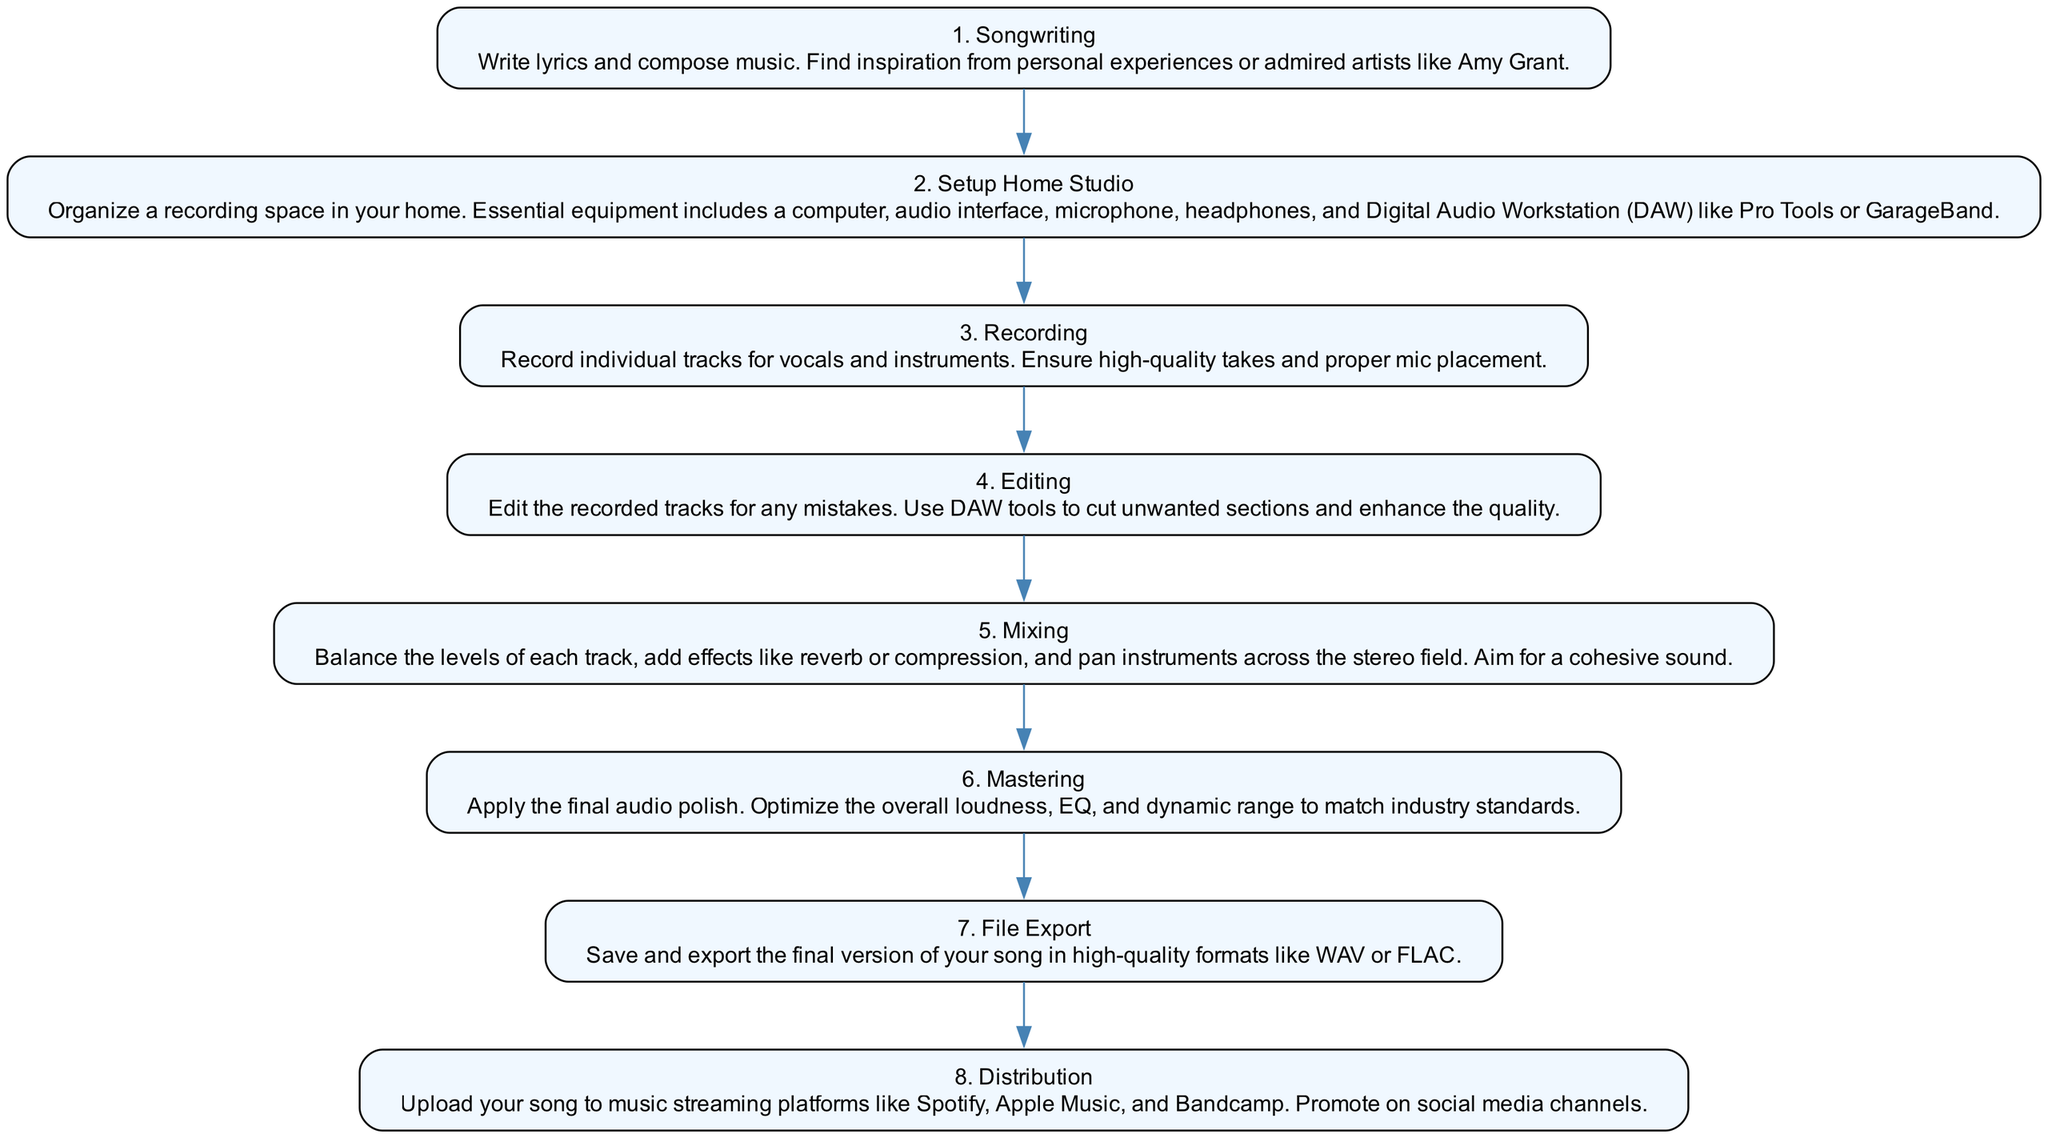What is the first step in the process? The diagram indicates that the first step is "Songwriting." By looking at the top of the flow chart, I can see the title for the first node, confirming that this is the initial action in the process.
Answer: Songwriting How many steps are included in the diagram? By counting the nodes from "Songwriting" to "Distribution," I can see that there are a total of eight distinct steps represented in the flow chart.
Answer: 8 What is the title of the last step? The final node in the flow chart is "Distribution." I observe the text in the last step and verify that it is correctly labeled.
Answer: Distribution Which step involves organizing a recording space? Upon examining the nodes, the second step "Setup Home Studio" focuses on organizing a space for recording. This is directly stated in the description of that specific step, confirming its purpose.
Answer: Setup Home Studio What is the main action in step 5? In step 5 titled "Mixing," the main action is to balance levels of each track, which suggests the importance of achieving a cohesive sound. This can be determined from the description that elaborates on the activities involved in this step.
Answer: Mixing What comes immediately after recording? The flow of the diagram shows that after the "Recording" step, the next action is "Editing." This is evident as there is a direct edge leading from the "Recording" node to the "Editing" node in the flow chart.
Answer: Editing How many types of audio formats are mentioned in the last step? Looking at the last step "File Export," it specifies high-quality formats like WAV or FLAC. Therefore, only two audio formats are discussed here, which I can count directly from the description.
Answer: 2 What is the purpose of the "Mastering" step? In step 6 labeled "Mastering," the purpose is to apply the final audio polish and optimize the overall sound to match industry standards. This is detailed in the description of that step, providing clarity on its role in the process.
Answer: Final audio polish 